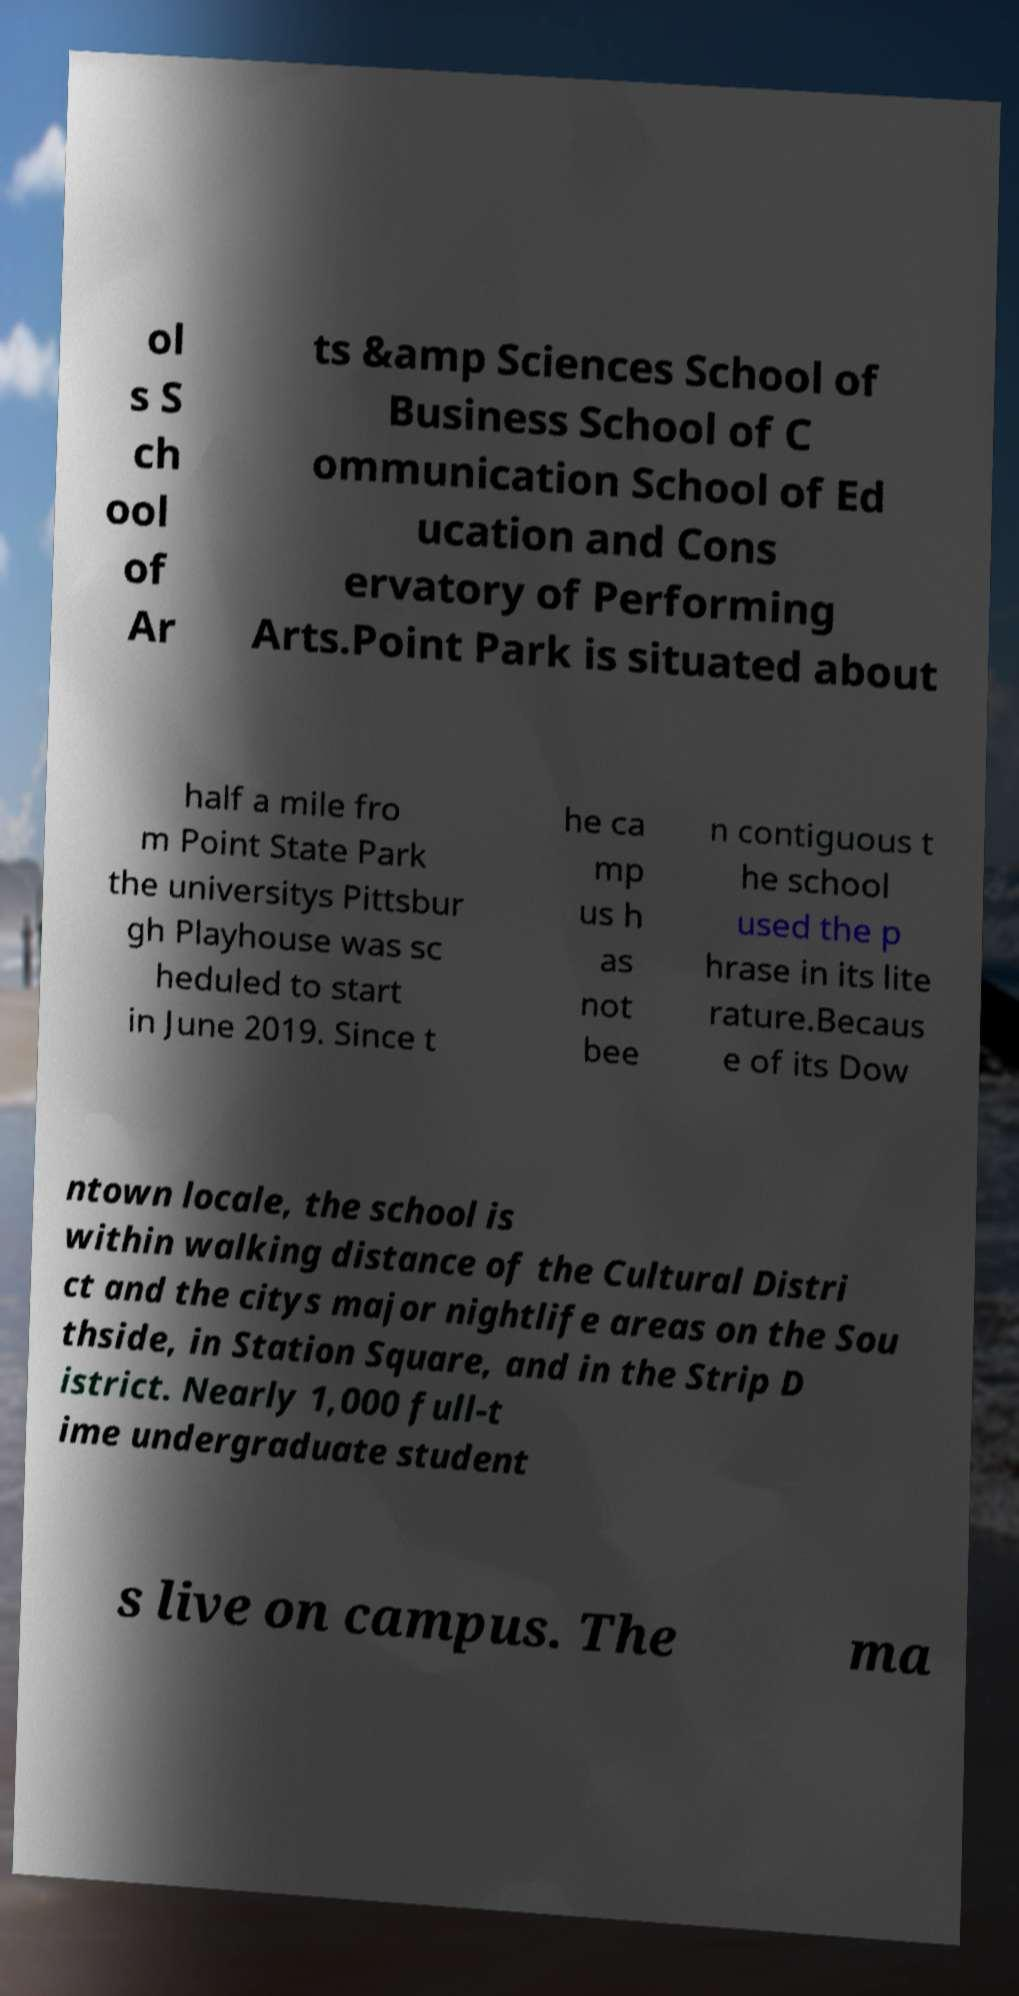For documentation purposes, I need the text within this image transcribed. Could you provide that? ol s S ch ool of Ar ts &amp Sciences School of Business School of C ommunication School of Ed ucation and Cons ervatory of Performing Arts.Point Park is situated about half a mile fro m Point State Park the universitys Pittsbur gh Playhouse was sc heduled to start in June 2019. Since t he ca mp us h as not bee n contiguous t he school used the p hrase in its lite rature.Becaus e of its Dow ntown locale, the school is within walking distance of the Cultural Distri ct and the citys major nightlife areas on the Sou thside, in Station Square, and in the Strip D istrict. Nearly 1,000 full-t ime undergraduate student s live on campus. The ma 